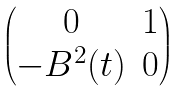Convert formula to latex. <formula><loc_0><loc_0><loc_500><loc_500>\begin{pmatrix} 0 & 1 \\ - B ^ { 2 } ( t ) & 0 \end{pmatrix}</formula> 